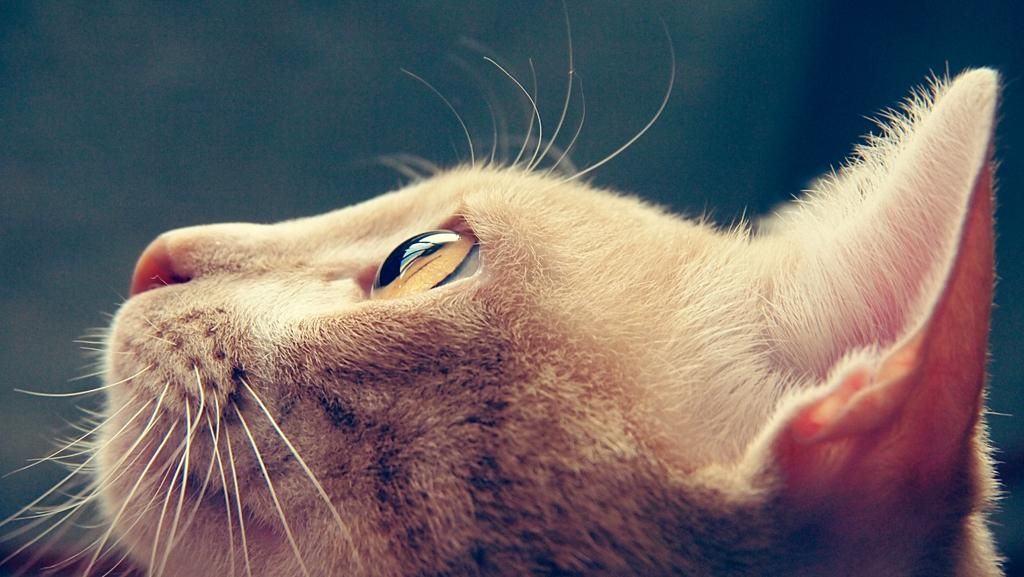What type of living creature is present in the image? There is an animal in the image. What type of account does the animal have in the image? There is no mention of an account or any financial aspect in the image; it simply features an animal. 